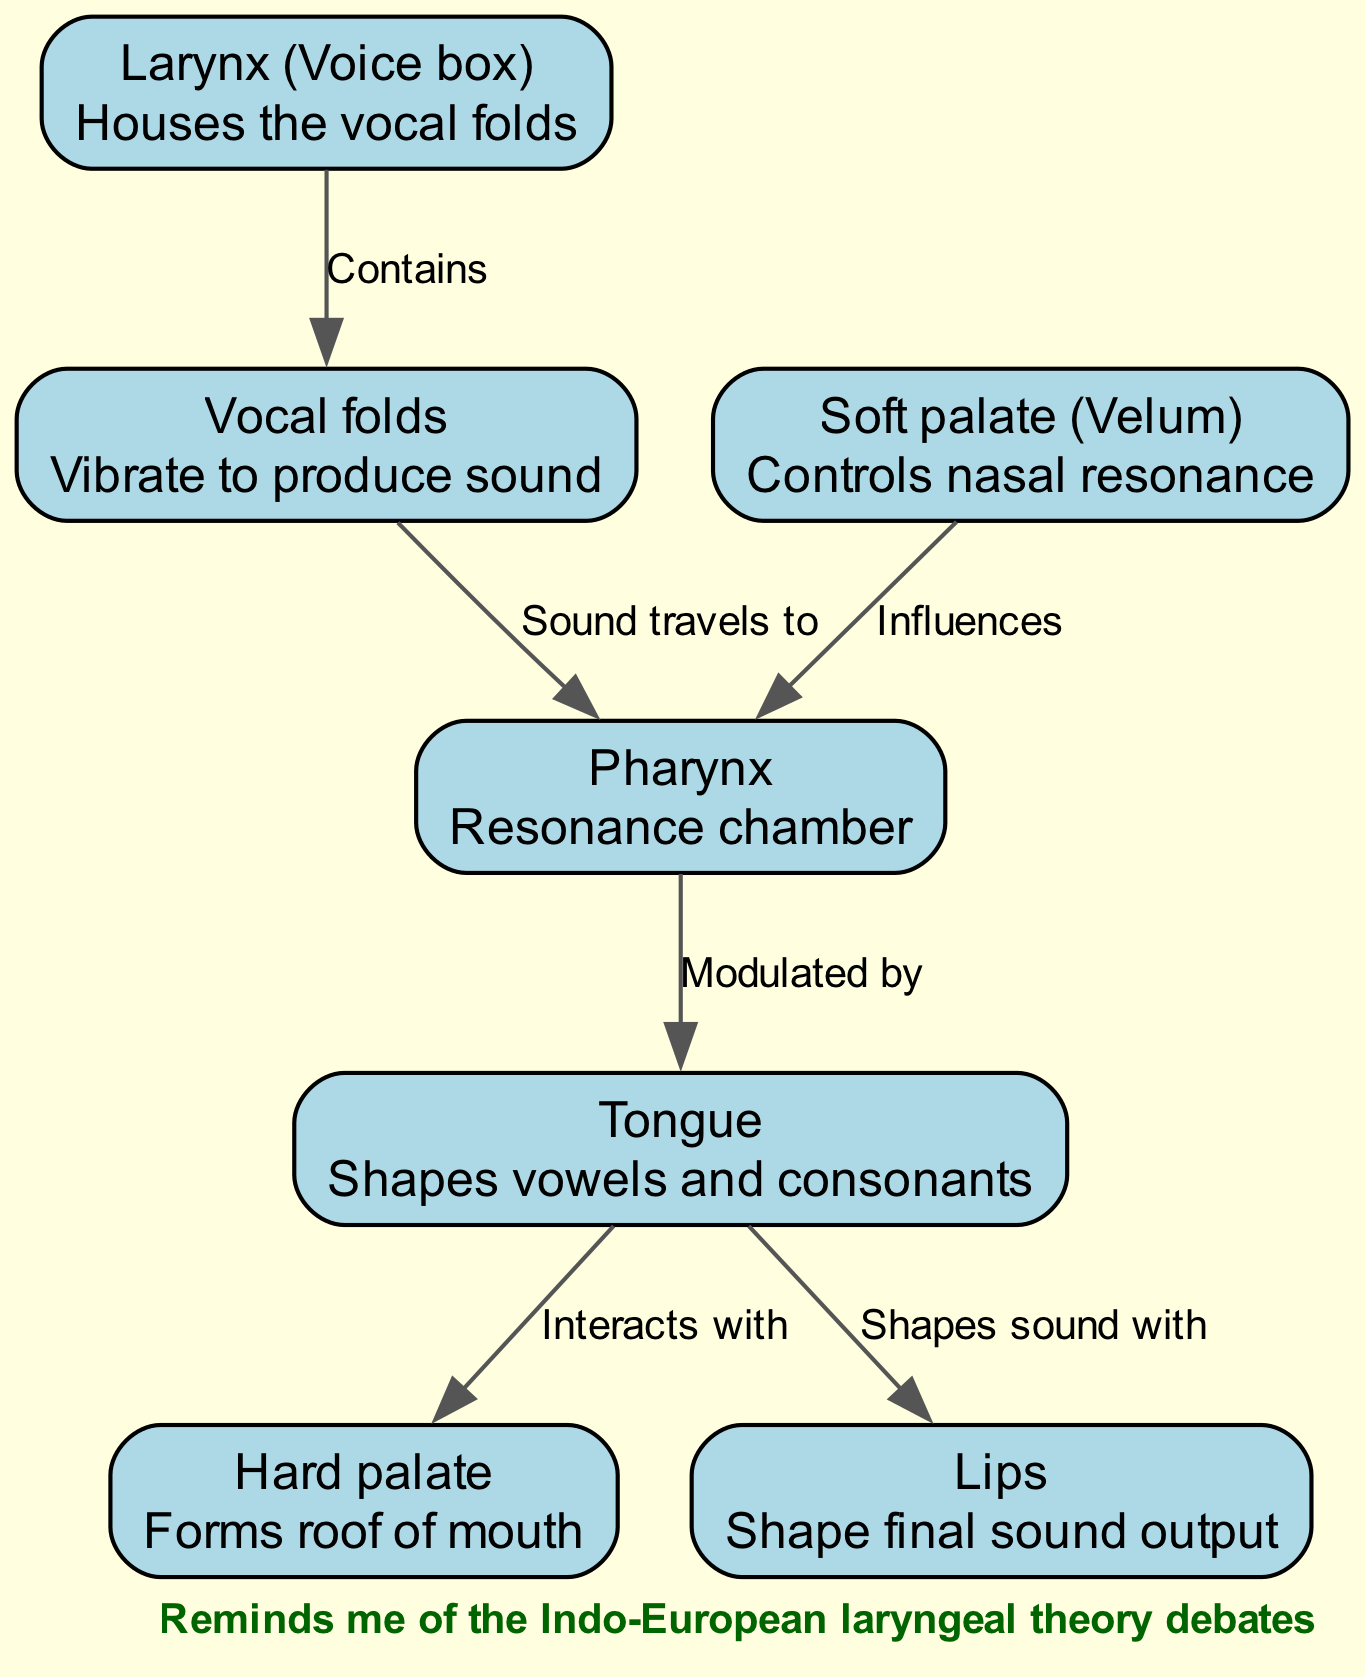What is the label of the anatomical structure that vibrates to produce sound? The diagram lists "Vocal folds" as the structure responsible for sound production. The label provided in the diagram clearly identifies the vocal folds with the description of their function.
Answer: Vocal folds How many nodes are present in the diagram? By counting the number of unique anatomical structures represented in the diagram, we find a total of six nodes: larynx, vocal folds, pharynx, tongue, soft palate, hard palate, and lips. This gives us the total number of nodes.
Answer: 7 What does the pharynx serve as in the context of this diagram? The diagram describes the pharynx as a "Resonance chamber," indicating its role in sound modulation within the vocal tract and highlighting its importance in speech production.
Answer: Resonance chamber Which structure influences the pharynx according to the diagram? The diagram connects the "Soft palate (Velum)" to the pharynx with the label "Influences." This indicates that the soft palate plays a role in shaping the resonance that occurs in the pharynx.
Answer: Soft palate What is the relationship between the tongue and the lips? The diagram illustrates that the tongue "Shapes sound with" the lips, indicating an interactive relationship where both structures work together during speech to modify sound output.
Answer: Shapes sound with Which structure can be found inside the larynx? The diagram indicates that the vocal folds are contained within the larynx, specifically stating this with the label "Contains," which explicitly identifies their location.
Answer: Vocal folds What role does the tongue have in shaping speech, as per the diagram? The diagram describes the tongue's function as "Shapes vowels and consonants," indicating its crucial role in articulating different speech sounds. This outlines the importance of the tongue in speech production.
Answer: Shapes vowels and consonants How does the tongue interact with the hard palate? According to the diagram, the edges show that the tongue "Interacts with" the hard palate, suggesting a cooperative function during the articulation process within the vocal tract.
Answer: Interacts with 